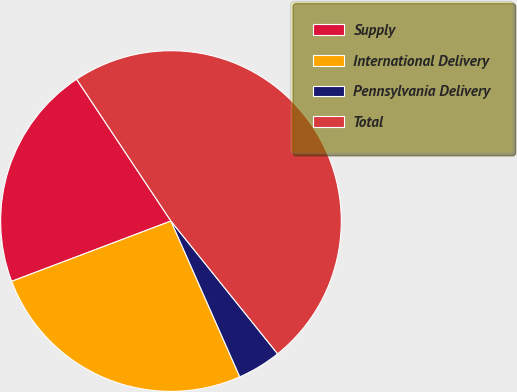<chart> <loc_0><loc_0><loc_500><loc_500><pie_chart><fcel>Supply<fcel>International Delivery<fcel>Pennsylvania Delivery<fcel>Total<nl><fcel>21.42%<fcel>25.86%<fcel>4.15%<fcel>48.57%<nl></chart> 